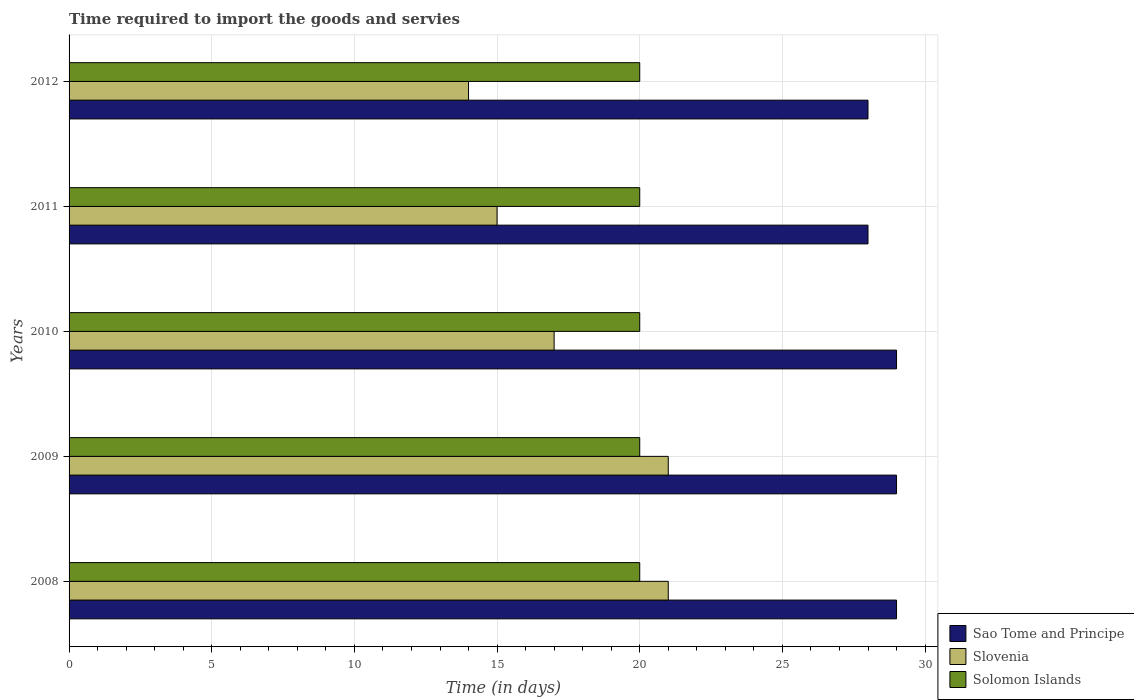How many groups of bars are there?
Offer a very short reply. 5. Are the number of bars on each tick of the Y-axis equal?
Your answer should be very brief. Yes. How many bars are there on the 2nd tick from the bottom?
Offer a terse response. 3. What is the number of days required to import the goods and services in Solomon Islands in 2010?
Your answer should be very brief. 20. Across all years, what is the maximum number of days required to import the goods and services in Sao Tome and Principe?
Your response must be concise. 29. Across all years, what is the minimum number of days required to import the goods and services in Solomon Islands?
Give a very brief answer. 20. In which year was the number of days required to import the goods and services in Sao Tome and Principe maximum?
Keep it short and to the point. 2008. What is the total number of days required to import the goods and services in Solomon Islands in the graph?
Your answer should be compact. 100. What is the difference between the number of days required to import the goods and services in Slovenia in 2009 and that in 2010?
Offer a terse response. 4. What is the difference between the number of days required to import the goods and services in Slovenia in 2010 and the number of days required to import the goods and services in Solomon Islands in 2011?
Your response must be concise. -3. What is the average number of days required to import the goods and services in Solomon Islands per year?
Ensure brevity in your answer.  20. In the year 2011, what is the difference between the number of days required to import the goods and services in Solomon Islands and number of days required to import the goods and services in Slovenia?
Ensure brevity in your answer.  5. What is the difference between the highest and the lowest number of days required to import the goods and services in Slovenia?
Your response must be concise. 7. In how many years, is the number of days required to import the goods and services in Slovenia greater than the average number of days required to import the goods and services in Slovenia taken over all years?
Offer a very short reply. 2. Is the sum of the number of days required to import the goods and services in Slovenia in 2008 and 2010 greater than the maximum number of days required to import the goods and services in Solomon Islands across all years?
Give a very brief answer. Yes. What does the 2nd bar from the top in 2010 represents?
Your answer should be compact. Slovenia. What does the 2nd bar from the bottom in 2008 represents?
Provide a short and direct response. Slovenia. Is it the case that in every year, the sum of the number of days required to import the goods and services in Slovenia and number of days required to import the goods and services in Solomon Islands is greater than the number of days required to import the goods and services in Sao Tome and Principe?
Provide a short and direct response. Yes. How many bars are there?
Give a very brief answer. 15. Are all the bars in the graph horizontal?
Your response must be concise. Yes. Are the values on the major ticks of X-axis written in scientific E-notation?
Provide a succinct answer. No. Does the graph contain grids?
Offer a terse response. Yes. How many legend labels are there?
Make the answer very short. 3. What is the title of the graph?
Provide a short and direct response. Time required to import the goods and servies. Does "Middle income" appear as one of the legend labels in the graph?
Make the answer very short. No. What is the label or title of the X-axis?
Provide a succinct answer. Time (in days). What is the Time (in days) in Sao Tome and Principe in 2008?
Make the answer very short. 29. What is the Time (in days) in Slovenia in 2008?
Your response must be concise. 21. What is the Time (in days) in Slovenia in 2009?
Offer a terse response. 21. What is the Time (in days) of Solomon Islands in 2009?
Offer a terse response. 20. What is the Time (in days) in Sao Tome and Principe in 2010?
Provide a short and direct response. 29. What is the Time (in days) in Solomon Islands in 2010?
Provide a succinct answer. 20. What is the Time (in days) of Sao Tome and Principe in 2011?
Offer a terse response. 28. What is the Time (in days) of Slovenia in 2011?
Keep it short and to the point. 15. What is the Time (in days) of Solomon Islands in 2011?
Keep it short and to the point. 20. What is the Time (in days) in Sao Tome and Principe in 2012?
Ensure brevity in your answer.  28. Across all years, what is the maximum Time (in days) in Slovenia?
Your response must be concise. 21. What is the total Time (in days) in Sao Tome and Principe in the graph?
Offer a terse response. 143. What is the total Time (in days) of Slovenia in the graph?
Offer a terse response. 88. What is the difference between the Time (in days) of Sao Tome and Principe in 2008 and that in 2009?
Your answer should be very brief. 0. What is the difference between the Time (in days) of Slovenia in 2008 and that in 2009?
Give a very brief answer. 0. What is the difference between the Time (in days) in Slovenia in 2008 and that in 2011?
Offer a terse response. 6. What is the difference between the Time (in days) of Solomon Islands in 2008 and that in 2011?
Keep it short and to the point. 0. What is the difference between the Time (in days) in Slovenia in 2008 and that in 2012?
Your answer should be very brief. 7. What is the difference between the Time (in days) in Solomon Islands in 2008 and that in 2012?
Your answer should be compact. 0. What is the difference between the Time (in days) of Slovenia in 2009 and that in 2010?
Your answer should be very brief. 4. What is the difference between the Time (in days) in Slovenia in 2009 and that in 2011?
Your response must be concise. 6. What is the difference between the Time (in days) in Sao Tome and Principe in 2009 and that in 2012?
Your answer should be compact. 1. What is the difference between the Time (in days) in Sao Tome and Principe in 2008 and the Time (in days) in Slovenia in 2009?
Give a very brief answer. 8. What is the difference between the Time (in days) in Sao Tome and Principe in 2008 and the Time (in days) in Solomon Islands in 2009?
Offer a very short reply. 9. What is the difference between the Time (in days) of Sao Tome and Principe in 2008 and the Time (in days) of Solomon Islands in 2010?
Keep it short and to the point. 9. What is the difference between the Time (in days) in Slovenia in 2008 and the Time (in days) in Solomon Islands in 2010?
Your answer should be compact. 1. What is the difference between the Time (in days) in Sao Tome and Principe in 2008 and the Time (in days) in Solomon Islands in 2011?
Offer a terse response. 9. What is the difference between the Time (in days) of Sao Tome and Principe in 2008 and the Time (in days) of Slovenia in 2012?
Give a very brief answer. 15. What is the difference between the Time (in days) of Sao Tome and Principe in 2008 and the Time (in days) of Solomon Islands in 2012?
Offer a very short reply. 9. What is the difference between the Time (in days) of Sao Tome and Principe in 2009 and the Time (in days) of Solomon Islands in 2010?
Keep it short and to the point. 9. What is the difference between the Time (in days) in Slovenia in 2009 and the Time (in days) in Solomon Islands in 2010?
Keep it short and to the point. 1. What is the difference between the Time (in days) of Sao Tome and Principe in 2009 and the Time (in days) of Slovenia in 2011?
Make the answer very short. 14. What is the difference between the Time (in days) in Slovenia in 2009 and the Time (in days) in Solomon Islands in 2011?
Provide a short and direct response. 1. What is the difference between the Time (in days) in Sao Tome and Principe in 2010 and the Time (in days) in Solomon Islands in 2011?
Give a very brief answer. 9. What is the difference between the Time (in days) in Sao Tome and Principe in 2010 and the Time (in days) in Slovenia in 2012?
Ensure brevity in your answer.  15. What is the difference between the Time (in days) in Sao Tome and Principe in 2010 and the Time (in days) in Solomon Islands in 2012?
Ensure brevity in your answer.  9. What is the difference between the Time (in days) of Slovenia in 2010 and the Time (in days) of Solomon Islands in 2012?
Make the answer very short. -3. What is the difference between the Time (in days) of Slovenia in 2011 and the Time (in days) of Solomon Islands in 2012?
Provide a succinct answer. -5. What is the average Time (in days) in Sao Tome and Principe per year?
Provide a short and direct response. 28.6. In the year 2008, what is the difference between the Time (in days) in Sao Tome and Principe and Time (in days) in Slovenia?
Offer a terse response. 8. In the year 2008, what is the difference between the Time (in days) of Slovenia and Time (in days) of Solomon Islands?
Offer a terse response. 1. In the year 2009, what is the difference between the Time (in days) of Sao Tome and Principe and Time (in days) of Solomon Islands?
Keep it short and to the point. 9. In the year 2009, what is the difference between the Time (in days) in Slovenia and Time (in days) in Solomon Islands?
Your response must be concise. 1. In the year 2010, what is the difference between the Time (in days) of Sao Tome and Principe and Time (in days) of Solomon Islands?
Your response must be concise. 9. In the year 2010, what is the difference between the Time (in days) of Slovenia and Time (in days) of Solomon Islands?
Offer a terse response. -3. In the year 2012, what is the difference between the Time (in days) in Sao Tome and Principe and Time (in days) in Slovenia?
Your answer should be very brief. 14. In the year 2012, what is the difference between the Time (in days) of Sao Tome and Principe and Time (in days) of Solomon Islands?
Ensure brevity in your answer.  8. In the year 2012, what is the difference between the Time (in days) of Slovenia and Time (in days) of Solomon Islands?
Give a very brief answer. -6. What is the ratio of the Time (in days) in Slovenia in 2008 to that in 2010?
Keep it short and to the point. 1.24. What is the ratio of the Time (in days) of Sao Tome and Principe in 2008 to that in 2011?
Provide a short and direct response. 1.04. What is the ratio of the Time (in days) in Sao Tome and Principe in 2008 to that in 2012?
Provide a short and direct response. 1.04. What is the ratio of the Time (in days) of Slovenia in 2008 to that in 2012?
Ensure brevity in your answer.  1.5. What is the ratio of the Time (in days) in Slovenia in 2009 to that in 2010?
Keep it short and to the point. 1.24. What is the ratio of the Time (in days) of Sao Tome and Principe in 2009 to that in 2011?
Your answer should be very brief. 1.04. What is the ratio of the Time (in days) in Sao Tome and Principe in 2009 to that in 2012?
Offer a very short reply. 1.04. What is the ratio of the Time (in days) of Slovenia in 2009 to that in 2012?
Keep it short and to the point. 1.5. What is the ratio of the Time (in days) of Sao Tome and Principe in 2010 to that in 2011?
Keep it short and to the point. 1.04. What is the ratio of the Time (in days) in Slovenia in 2010 to that in 2011?
Provide a short and direct response. 1.13. What is the ratio of the Time (in days) in Sao Tome and Principe in 2010 to that in 2012?
Provide a short and direct response. 1.04. What is the ratio of the Time (in days) in Slovenia in 2010 to that in 2012?
Your response must be concise. 1.21. What is the ratio of the Time (in days) of Slovenia in 2011 to that in 2012?
Your answer should be compact. 1.07. What is the ratio of the Time (in days) in Solomon Islands in 2011 to that in 2012?
Your answer should be very brief. 1. What is the difference between the highest and the second highest Time (in days) of Slovenia?
Provide a succinct answer. 0. What is the difference between the highest and the lowest Time (in days) in Sao Tome and Principe?
Provide a short and direct response. 1. What is the difference between the highest and the lowest Time (in days) of Slovenia?
Provide a short and direct response. 7. 